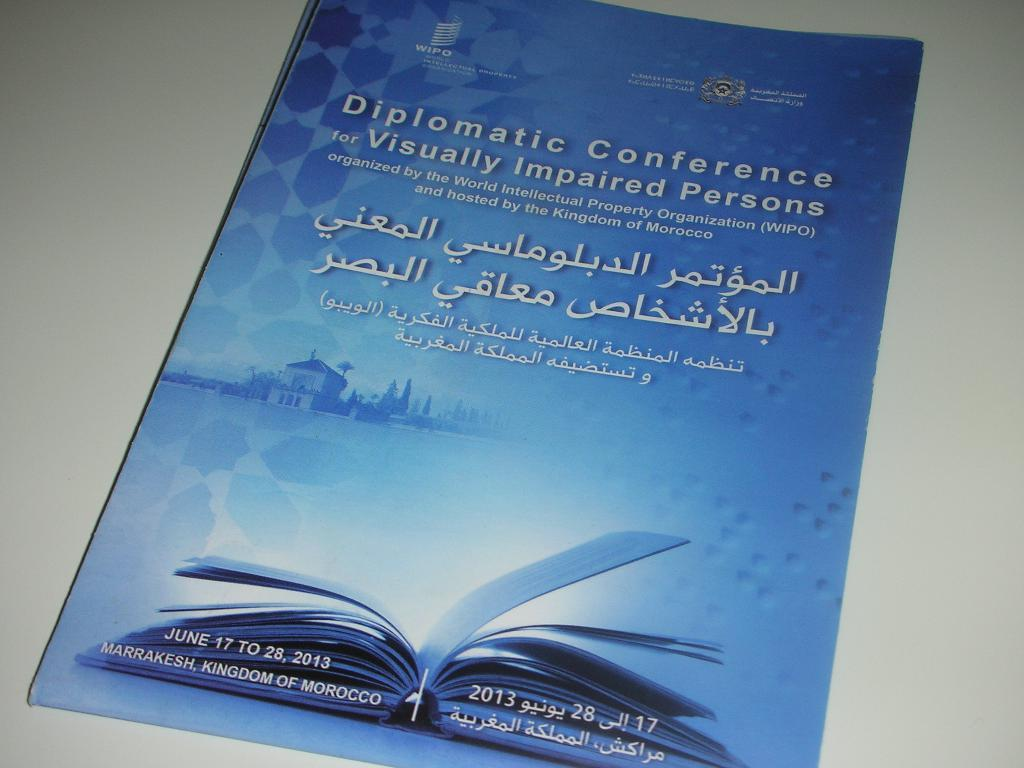<image>
Offer a succinct explanation of the picture presented. A flyer for the Diplomatic Conference for visually impaired persons. 